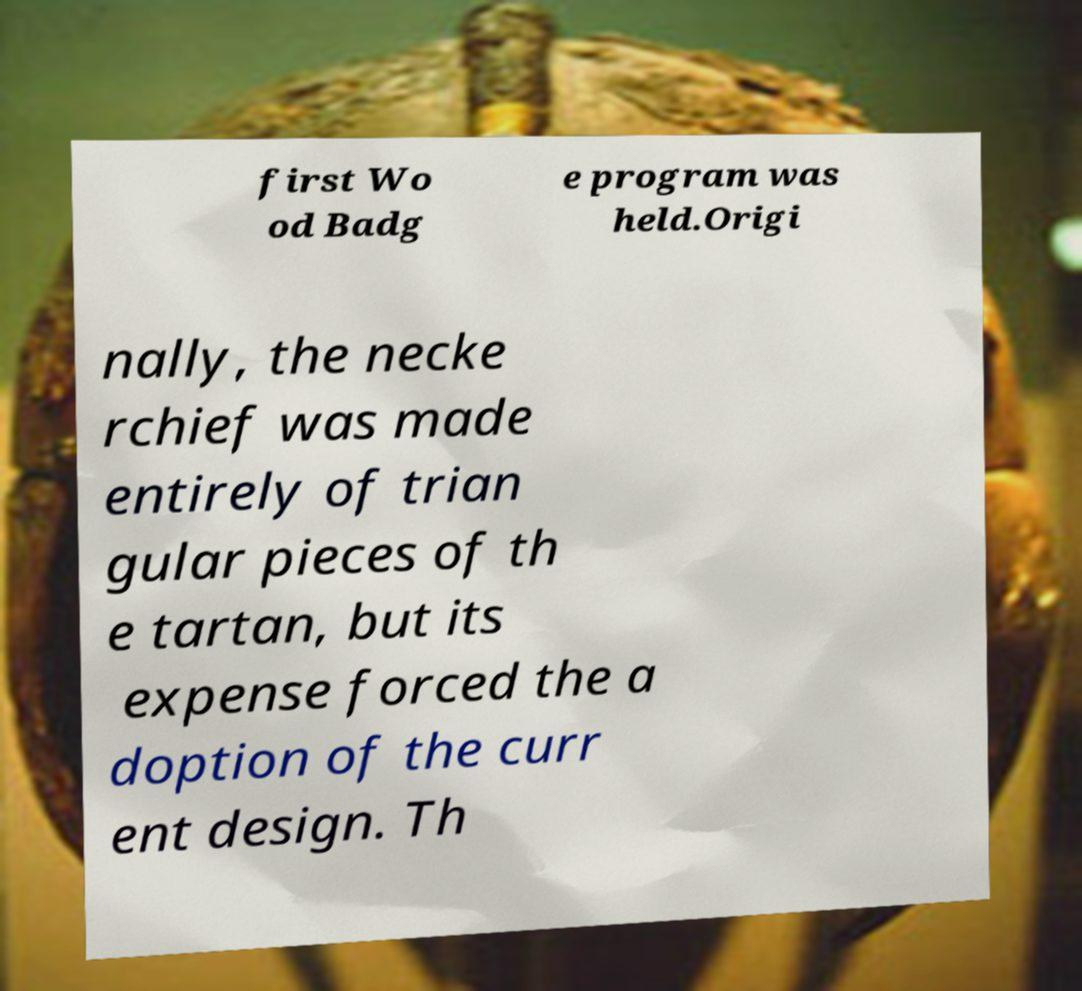For documentation purposes, I need the text within this image transcribed. Could you provide that? first Wo od Badg e program was held.Origi nally, the necke rchief was made entirely of trian gular pieces of th e tartan, but its expense forced the a doption of the curr ent design. Th 